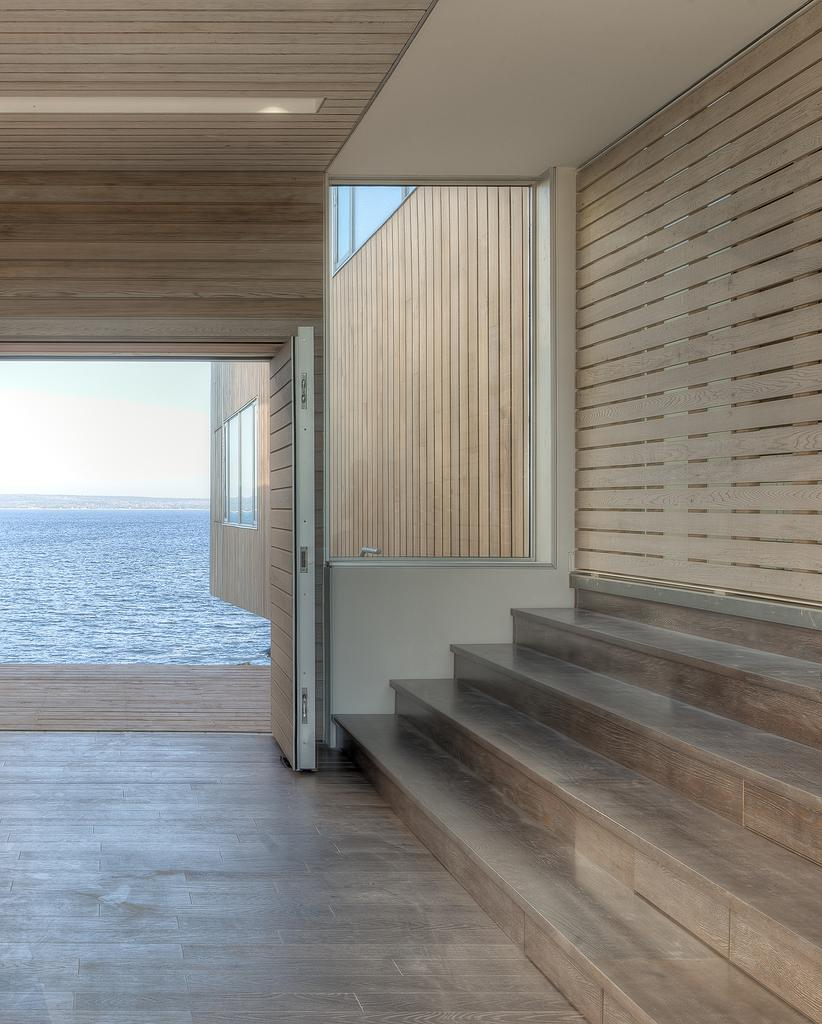What type of surface is visible at the bottom of the image? There is a floor in the image. What type of vertical structure is visible in the image? There is a wall in the image. What type of architectural feature allows for movement between different levels in the image? There are stairs in the image. What type of opening is visible in the wall in the image? There are windows in the image. What type of illumination is visible at the top of the image? There is light visible at the top of the image. What type of natural environment is visible in the background of the image? There is water and sky visible in the background of the image. How many cherries are hanging from the wall in the image? There are no cherries visible in the image. What type of financial gain is associated with the stairs in the image? There is no mention of profit or financial gain in the image. 